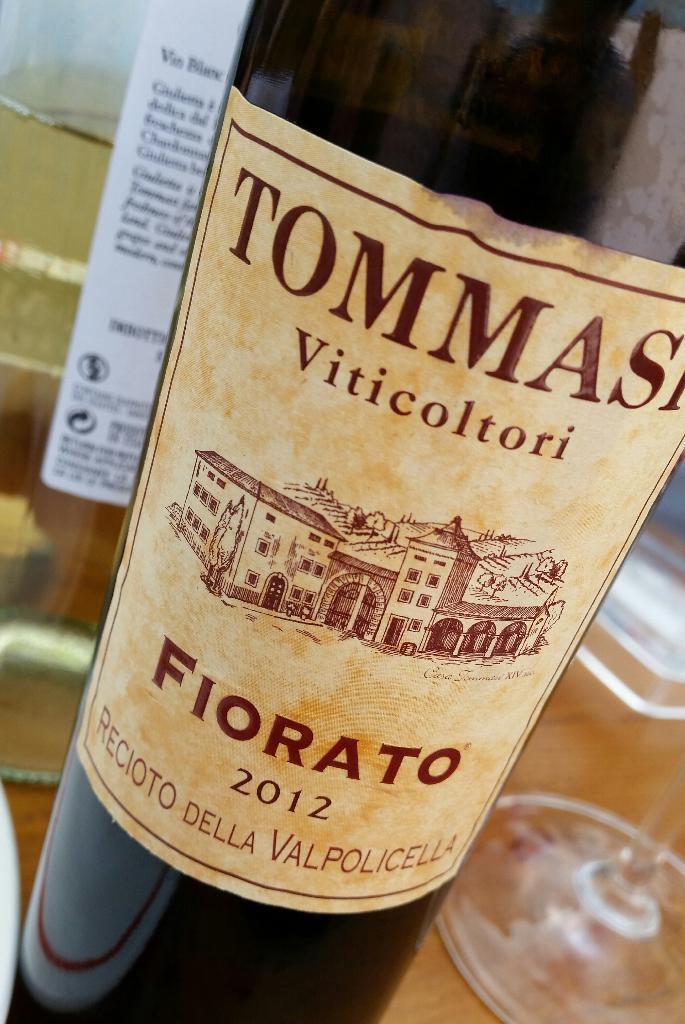<image>
Create a compact narrative representing the image presented. A bottle of 2012 Fiorato has a building on the label. 